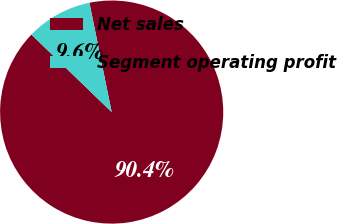<chart> <loc_0><loc_0><loc_500><loc_500><pie_chart><fcel>Net sales<fcel>Segment operating profit<nl><fcel>90.41%<fcel>9.59%<nl></chart> 